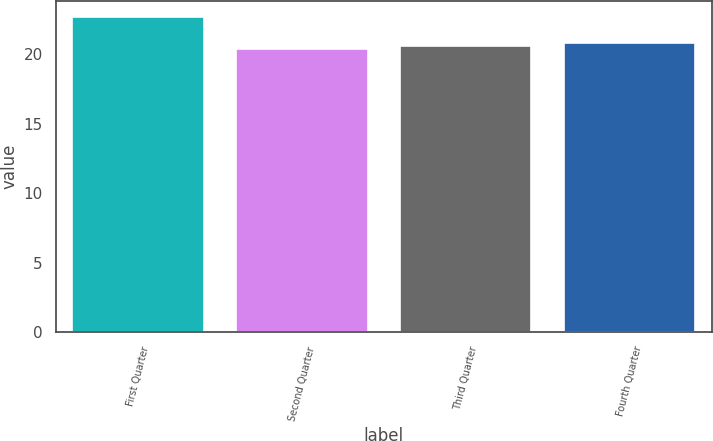Convert chart. <chart><loc_0><loc_0><loc_500><loc_500><bar_chart><fcel>First Quarter<fcel>Second Quarter<fcel>Third Quarter<fcel>Fourth Quarter<nl><fcel>22.7<fcel>20.35<fcel>20.59<fcel>20.82<nl></chart> 